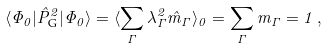Convert formula to latex. <formula><loc_0><loc_0><loc_500><loc_500>\langle \Phi _ { 0 } | \hat { P } _ { \text {G} } ^ { 2 } | \Phi _ { 0 } \rangle = \langle \sum _ { \Gamma } \lambda _ { \Gamma } ^ { 2 } \hat { m } _ { \Gamma } \rangle _ { 0 } = \sum _ { \Gamma } m _ { \Gamma } = 1 \, ,</formula> 